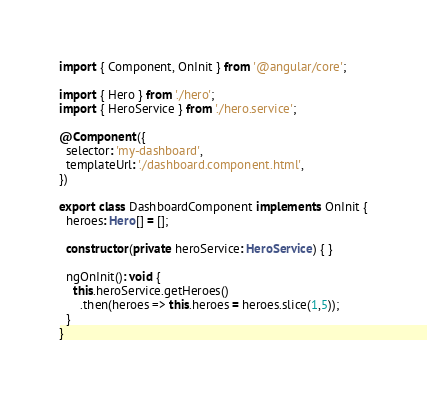Convert code to text. <code><loc_0><loc_0><loc_500><loc_500><_TypeScript_>import { Component, OnInit } from '@angular/core';

import { Hero } from './hero';
import { HeroService } from './hero.service';

@Component({
  selector: 'my-dashboard',
  templateUrl: './dashboard.component.html',
})

export class DashboardComponent implements OnInit {
  heroes: Hero[] = [];

  constructor(private heroService: HeroService) { }

  ngOnInit(): void {
    this.heroService.getHeroes()
      .then(heroes => this.heroes = heroes.slice(1,5));
  }
}
</code> 